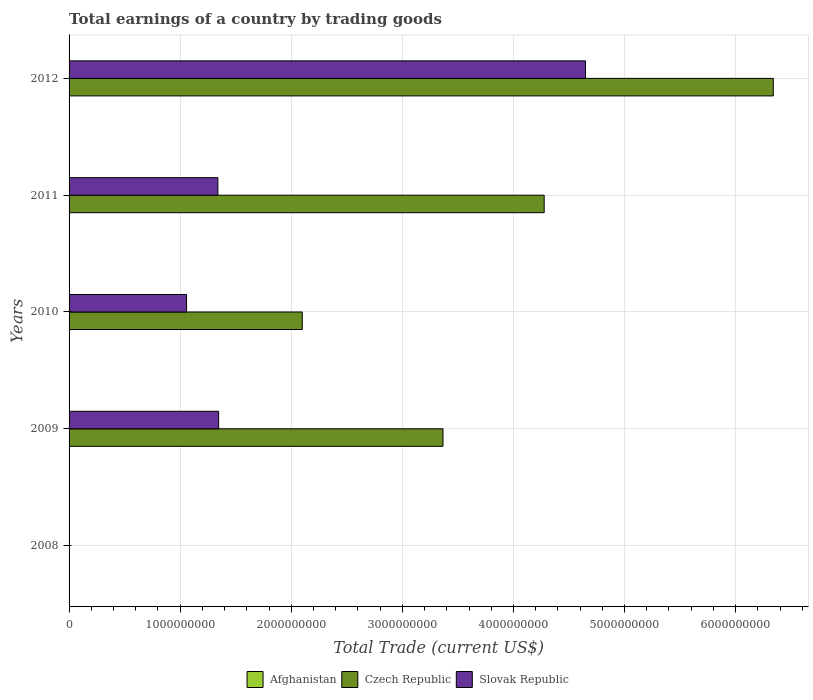What is the label of the 3rd group of bars from the top?
Provide a short and direct response. 2010. In how many cases, is the number of bars for a given year not equal to the number of legend labels?
Keep it short and to the point. 5. What is the total earnings in Slovak Republic in 2012?
Ensure brevity in your answer.  4.65e+09. Across all years, what is the maximum total earnings in Czech Republic?
Make the answer very short. 6.34e+09. What is the total total earnings in Slovak Republic in the graph?
Your answer should be very brief. 8.39e+09. What is the difference between the total earnings in Slovak Republic in 2011 and that in 2012?
Ensure brevity in your answer.  -3.31e+09. What is the difference between the total earnings in Slovak Republic in 2011 and the total earnings in Afghanistan in 2012?
Provide a short and direct response. 1.34e+09. In the year 2009, what is the difference between the total earnings in Czech Republic and total earnings in Slovak Republic?
Make the answer very short. 2.02e+09. In how many years, is the total earnings in Afghanistan greater than 3600000000 US$?
Give a very brief answer. 0. What is the ratio of the total earnings in Czech Republic in 2010 to that in 2012?
Your response must be concise. 0.33. Is the difference between the total earnings in Czech Republic in 2010 and 2012 greater than the difference between the total earnings in Slovak Republic in 2010 and 2012?
Keep it short and to the point. No. What is the difference between the highest and the second highest total earnings in Czech Republic?
Keep it short and to the point. 2.06e+09. What is the difference between the highest and the lowest total earnings in Slovak Republic?
Provide a short and direct response. 4.65e+09. Is it the case that in every year, the sum of the total earnings in Slovak Republic and total earnings in Afghanistan is greater than the total earnings in Czech Republic?
Give a very brief answer. No. How many bars are there?
Make the answer very short. 8. Are all the bars in the graph horizontal?
Your answer should be compact. Yes. How many years are there in the graph?
Give a very brief answer. 5. What is the difference between two consecutive major ticks on the X-axis?
Keep it short and to the point. 1.00e+09. Does the graph contain any zero values?
Offer a terse response. Yes. Does the graph contain grids?
Give a very brief answer. Yes. Where does the legend appear in the graph?
Your answer should be very brief. Bottom center. How many legend labels are there?
Give a very brief answer. 3. How are the legend labels stacked?
Keep it short and to the point. Horizontal. What is the title of the graph?
Give a very brief answer. Total earnings of a country by trading goods. What is the label or title of the X-axis?
Your answer should be very brief. Total Trade (current US$). What is the label or title of the Y-axis?
Ensure brevity in your answer.  Years. What is the Total Trade (current US$) of Czech Republic in 2008?
Make the answer very short. 0. What is the Total Trade (current US$) in Czech Republic in 2009?
Provide a succinct answer. 3.37e+09. What is the Total Trade (current US$) of Slovak Republic in 2009?
Keep it short and to the point. 1.35e+09. What is the Total Trade (current US$) in Afghanistan in 2010?
Provide a short and direct response. 0. What is the Total Trade (current US$) in Czech Republic in 2010?
Provide a short and direct response. 2.10e+09. What is the Total Trade (current US$) in Slovak Republic in 2010?
Make the answer very short. 1.06e+09. What is the Total Trade (current US$) in Afghanistan in 2011?
Your answer should be very brief. 0. What is the Total Trade (current US$) in Czech Republic in 2011?
Offer a terse response. 4.28e+09. What is the Total Trade (current US$) in Slovak Republic in 2011?
Your answer should be very brief. 1.34e+09. What is the Total Trade (current US$) of Czech Republic in 2012?
Give a very brief answer. 6.34e+09. What is the Total Trade (current US$) of Slovak Republic in 2012?
Provide a succinct answer. 4.65e+09. Across all years, what is the maximum Total Trade (current US$) in Czech Republic?
Offer a terse response. 6.34e+09. Across all years, what is the maximum Total Trade (current US$) of Slovak Republic?
Your response must be concise. 4.65e+09. Across all years, what is the minimum Total Trade (current US$) of Czech Republic?
Your answer should be compact. 0. Across all years, what is the minimum Total Trade (current US$) in Slovak Republic?
Offer a terse response. 0. What is the total Total Trade (current US$) in Afghanistan in the graph?
Give a very brief answer. 0. What is the total Total Trade (current US$) in Czech Republic in the graph?
Offer a terse response. 1.61e+1. What is the total Total Trade (current US$) in Slovak Republic in the graph?
Offer a very short reply. 8.39e+09. What is the difference between the Total Trade (current US$) of Czech Republic in 2009 and that in 2010?
Offer a terse response. 1.27e+09. What is the difference between the Total Trade (current US$) of Slovak Republic in 2009 and that in 2010?
Offer a very short reply. 2.89e+08. What is the difference between the Total Trade (current US$) in Czech Republic in 2009 and that in 2011?
Give a very brief answer. -9.11e+08. What is the difference between the Total Trade (current US$) of Slovak Republic in 2009 and that in 2011?
Your answer should be very brief. 7.18e+06. What is the difference between the Total Trade (current US$) of Czech Republic in 2009 and that in 2012?
Provide a short and direct response. -2.97e+09. What is the difference between the Total Trade (current US$) of Slovak Republic in 2009 and that in 2012?
Make the answer very short. -3.30e+09. What is the difference between the Total Trade (current US$) in Czech Republic in 2010 and that in 2011?
Your answer should be very brief. -2.18e+09. What is the difference between the Total Trade (current US$) of Slovak Republic in 2010 and that in 2011?
Your answer should be very brief. -2.82e+08. What is the difference between the Total Trade (current US$) of Czech Republic in 2010 and that in 2012?
Offer a very short reply. -4.24e+09. What is the difference between the Total Trade (current US$) in Slovak Republic in 2010 and that in 2012?
Give a very brief answer. -3.59e+09. What is the difference between the Total Trade (current US$) of Czech Republic in 2011 and that in 2012?
Your answer should be compact. -2.06e+09. What is the difference between the Total Trade (current US$) in Slovak Republic in 2011 and that in 2012?
Offer a terse response. -3.31e+09. What is the difference between the Total Trade (current US$) in Czech Republic in 2009 and the Total Trade (current US$) in Slovak Republic in 2010?
Your response must be concise. 2.31e+09. What is the difference between the Total Trade (current US$) of Czech Republic in 2009 and the Total Trade (current US$) of Slovak Republic in 2011?
Ensure brevity in your answer.  2.03e+09. What is the difference between the Total Trade (current US$) of Czech Republic in 2009 and the Total Trade (current US$) of Slovak Republic in 2012?
Your answer should be compact. -1.28e+09. What is the difference between the Total Trade (current US$) in Czech Republic in 2010 and the Total Trade (current US$) in Slovak Republic in 2011?
Your response must be concise. 7.60e+08. What is the difference between the Total Trade (current US$) in Czech Republic in 2010 and the Total Trade (current US$) in Slovak Republic in 2012?
Make the answer very short. -2.55e+09. What is the difference between the Total Trade (current US$) of Czech Republic in 2011 and the Total Trade (current US$) of Slovak Republic in 2012?
Keep it short and to the point. -3.72e+08. What is the average Total Trade (current US$) in Afghanistan per year?
Keep it short and to the point. 0. What is the average Total Trade (current US$) of Czech Republic per year?
Your response must be concise. 3.22e+09. What is the average Total Trade (current US$) in Slovak Republic per year?
Your answer should be compact. 1.68e+09. In the year 2009, what is the difference between the Total Trade (current US$) of Czech Republic and Total Trade (current US$) of Slovak Republic?
Keep it short and to the point. 2.02e+09. In the year 2010, what is the difference between the Total Trade (current US$) of Czech Republic and Total Trade (current US$) of Slovak Republic?
Provide a short and direct response. 1.04e+09. In the year 2011, what is the difference between the Total Trade (current US$) in Czech Republic and Total Trade (current US$) in Slovak Republic?
Your answer should be very brief. 2.94e+09. In the year 2012, what is the difference between the Total Trade (current US$) in Czech Republic and Total Trade (current US$) in Slovak Republic?
Ensure brevity in your answer.  1.69e+09. What is the ratio of the Total Trade (current US$) in Czech Republic in 2009 to that in 2010?
Ensure brevity in your answer.  1.6. What is the ratio of the Total Trade (current US$) of Slovak Republic in 2009 to that in 2010?
Offer a terse response. 1.27. What is the ratio of the Total Trade (current US$) of Czech Republic in 2009 to that in 2011?
Your answer should be very brief. 0.79. What is the ratio of the Total Trade (current US$) of Slovak Republic in 2009 to that in 2011?
Your answer should be compact. 1.01. What is the ratio of the Total Trade (current US$) in Czech Republic in 2009 to that in 2012?
Provide a succinct answer. 0.53. What is the ratio of the Total Trade (current US$) of Slovak Republic in 2009 to that in 2012?
Provide a short and direct response. 0.29. What is the ratio of the Total Trade (current US$) of Czech Republic in 2010 to that in 2011?
Your response must be concise. 0.49. What is the ratio of the Total Trade (current US$) of Slovak Republic in 2010 to that in 2011?
Your answer should be compact. 0.79. What is the ratio of the Total Trade (current US$) of Czech Republic in 2010 to that in 2012?
Offer a very short reply. 0.33. What is the ratio of the Total Trade (current US$) in Slovak Republic in 2010 to that in 2012?
Provide a short and direct response. 0.23. What is the ratio of the Total Trade (current US$) of Czech Republic in 2011 to that in 2012?
Offer a very short reply. 0.67. What is the ratio of the Total Trade (current US$) in Slovak Republic in 2011 to that in 2012?
Offer a very short reply. 0.29. What is the difference between the highest and the second highest Total Trade (current US$) in Czech Republic?
Your answer should be very brief. 2.06e+09. What is the difference between the highest and the second highest Total Trade (current US$) in Slovak Republic?
Your answer should be compact. 3.30e+09. What is the difference between the highest and the lowest Total Trade (current US$) in Czech Republic?
Offer a very short reply. 6.34e+09. What is the difference between the highest and the lowest Total Trade (current US$) in Slovak Republic?
Give a very brief answer. 4.65e+09. 